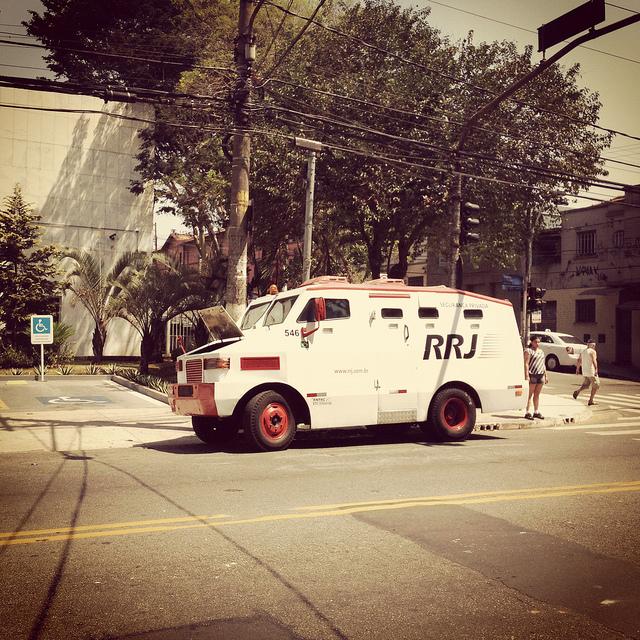Are people wearing shorts?
Keep it brief. Yes. What is the logo on the truck?
Quick response, please. Rrj. What kind of vehicle is this white one?
Give a very brief answer. Van. 